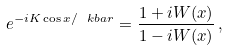Convert formula to latex. <formula><loc_0><loc_0><loc_500><loc_500>e ^ { - i K \cos x / \ k b a r } = \frac { 1 + i W ( x ) } { 1 - i W ( x ) } \, ,</formula> 